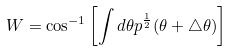<formula> <loc_0><loc_0><loc_500><loc_500>W = \cos ^ { - 1 } \left [ \int d \theta p ^ { \frac { 1 } { 2 } } ( \theta + \triangle \theta ) \right ]</formula> 